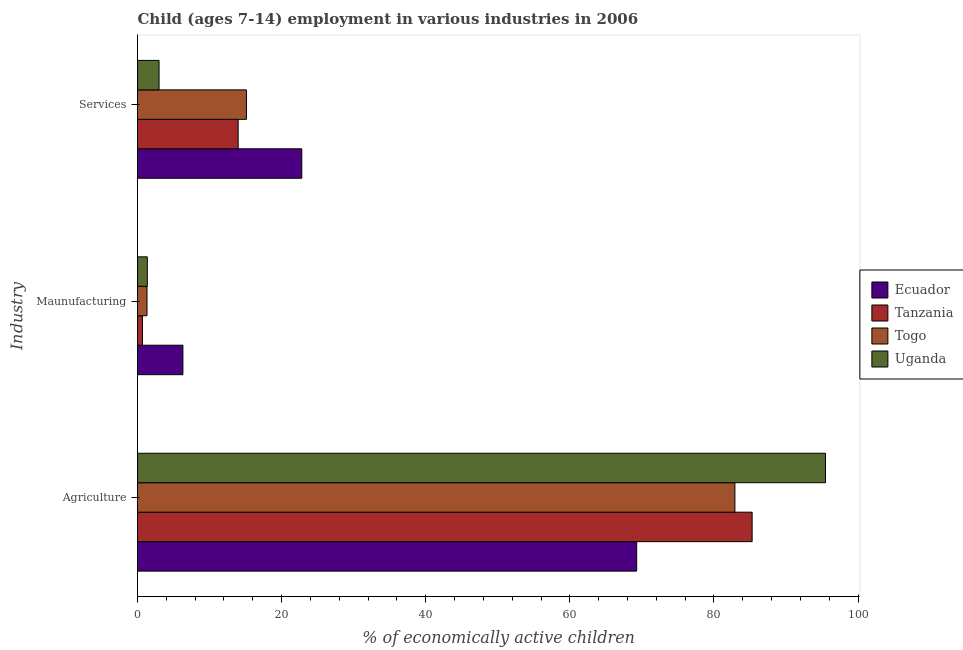Are the number of bars per tick equal to the number of legend labels?
Offer a very short reply. Yes. What is the label of the 3rd group of bars from the top?
Your answer should be very brief. Agriculture. What is the percentage of economically active children in manufacturing in Tanzania?
Provide a succinct answer. 0.69. Across all countries, what is the maximum percentage of economically active children in services?
Keep it short and to the point. 22.8. Across all countries, what is the minimum percentage of economically active children in manufacturing?
Keep it short and to the point. 0.69. In which country was the percentage of economically active children in agriculture maximum?
Give a very brief answer. Uganda. In which country was the percentage of economically active children in manufacturing minimum?
Give a very brief answer. Tanzania. What is the total percentage of economically active children in services in the graph?
Provide a succinct answer. 54.88. What is the difference between the percentage of economically active children in services in Uganda and that in Togo?
Give a very brief answer. -12.13. What is the difference between the percentage of economically active children in services in Ecuador and the percentage of economically active children in agriculture in Togo?
Ensure brevity in your answer.  -60.11. What is the average percentage of economically active children in agriculture per country?
Make the answer very short. 83.24. What is the difference between the percentage of economically active children in services and percentage of economically active children in agriculture in Ecuador?
Provide a succinct answer. -46.48. In how many countries, is the percentage of economically active children in services greater than 52 %?
Offer a terse response. 0. What is the ratio of the percentage of economically active children in agriculture in Ecuador to that in Tanzania?
Provide a succinct answer. 0.81. Is the percentage of economically active children in services in Ecuador less than that in Tanzania?
Provide a short and direct response. No. Is the difference between the percentage of economically active children in manufacturing in Uganda and Ecuador greater than the difference between the percentage of economically active children in services in Uganda and Ecuador?
Your answer should be compact. Yes. What is the difference between the highest and the second highest percentage of economically active children in manufacturing?
Your answer should be very brief. 4.94. What is the difference between the highest and the lowest percentage of economically active children in agriculture?
Make the answer very short. 26.2. In how many countries, is the percentage of economically active children in services greater than the average percentage of economically active children in services taken over all countries?
Offer a terse response. 3. Is the sum of the percentage of economically active children in services in Uganda and Tanzania greater than the maximum percentage of economically active children in manufacturing across all countries?
Offer a very short reply. Yes. What does the 3rd bar from the top in Services represents?
Make the answer very short. Tanzania. What does the 4th bar from the bottom in Agriculture represents?
Ensure brevity in your answer.  Uganda. How many bars are there?
Provide a succinct answer. 12. How many countries are there in the graph?
Your answer should be compact. 4. How many legend labels are there?
Provide a succinct answer. 4. How are the legend labels stacked?
Your answer should be compact. Vertical. What is the title of the graph?
Your answer should be very brief. Child (ages 7-14) employment in various industries in 2006. What is the label or title of the X-axis?
Ensure brevity in your answer.  % of economically active children. What is the label or title of the Y-axis?
Make the answer very short. Industry. What is the % of economically active children in Ecuador in Agriculture?
Offer a terse response. 69.28. What is the % of economically active children in Tanzania in Agriculture?
Provide a short and direct response. 85.3. What is the % of economically active children in Togo in Agriculture?
Give a very brief answer. 82.91. What is the % of economically active children of Uganda in Agriculture?
Your answer should be very brief. 95.48. What is the % of economically active children in Ecuador in Maunufacturing?
Your response must be concise. 6.3. What is the % of economically active children in Tanzania in Maunufacturing?
Keep it short and to the point. 0.69. What is the % of economically active children of Togo in Maunufacturing?
Your response must be concise. 1.32. What is the % of economically active children of Uganda in Maunufacturing?
Ensure brevity in your answer.  1.36. What is the % of economically active children in Ecuador in Services?
Your response must be concise. 22.8. What is the % of economically active children of Tanzania in Services?
Provide a succinct answer. 13.97. What is the % of economically active children of Togo in Services?
Offer a terse response. 15.12. What is the % of economically active children in Uganda in Services?
Give a very brief answer. 2.99. Across all Industry, what is the maximum % of economically active children in Ecuador?
Your response must be concise. 69.28. Across all Industry, what is the maximum % of economically active children of Tanzania?
Offer a terse response. 85.3. Across all Industry, what is the maximum % of economically active children of Togo?
Offer a terse response. 82.91. Across all Industry, what is the maximum % of economically active children in Uganda?
Make the answer very short. 95.48. Across all Industry, what is the minimum % of economically active children in Ecuador?
Offer a very short reply. 6.3. Across all Industry, what is the minimum % of economically active children in Tanzania?
Offer a very short reply. 0.69. Across all Industry, what is the minimum % of economically active children in Togo?
Keep it short and to the point. 1.32. Across all Industry, what is the minimum % of economically active children in Uganda?
Offer a terse response. 1.36. What is the total % of economically active children of Ecuador in the graph?
Your response must be concise. 98.38. What is the total % of economically active children in Tanzania in the graph?
Offer a very short reply. 99.96. What is the total % of economically active children of Togo in the graph?
Your response must be concise. 99.35. What is the total % of economically active children in Uganda in the graph?
Your answer should be very brief. 99.83. What is the difference between the % of economically active children of Ecuador in Agriculture and that in Maunufacturing?
Provide a short and direct response. 62.98. What is the difference between the % of economically active children of Tanzania in Agriculture and that in Maunufacturing?
Your response must be concise. 84.61. What is the difference between the % of economically active children in Togo in Agriculture and that in Maunufacturing?
Ensure brevity in your answer.  81.59. What is the difference between the % of economically active children of Uganda in Agriculture and that in Maunufacturing?
Provide a short and direct response. 94.12. What is the difference between the % of economically active children in Ecuador in Agriculture and that in Services?
Your response must be concise. 46.48. What is the difference between the % of economically active children in Tanzania in Agriculture and that in Services?
Make the answer very short. 71.33. What is the difference between the % of economically active children in Togo in Agriculture and that in Services?
Your answer should be very brief. 67.79. What is the difference between the % of economically active children in Uganda in Agriculture and that in Services?
Offer a terse response. 92.49. What is the difference between the % of economically active children in Ecuador in Maunufacturing and that in Services?
Make the answer very short. -16.5. What is the difference between the % of economically active children in Tanzania in Maunufacturing and that in Services?
Your response must be concise. -13.28. What is the difference between the % of economically active children of Togo in Maunufacturing and that in Services?
Your answer should be compact. -13.8. What is the difference between the % of economically active children of Uganda in Maunufacturing and that in Services?
Ensure brevity in your answer.  -1.63. What is the difference between the % of economically active children of Ecuador in Agriculture and the % of economically active children of Tanzania in Maunufacturing?
Offer a terse response. 68.59. What is the difference between the % of economically active children in Ecuador in Agriculture and the % of economically active children in Togo in Maunufacturing?
Your response must be concise. 67.96. What is the difference between the % of economically active children in Ecuador in Agriculture and the % of economically active children in Uganda in Maunufacturing?
Your answer should be compact. 67.92. What is the difference between the % of economically active children of Tanzania in Agriculture and the % of economically active children of Togo in Maunufacturing?
Make the answer very short. 83.98. What is the difference between the % of economically active children of Tanzania in Agriculture and the % of economically active children of Uganda in Maunufacturing?
Give a very brief answer. 83.94. What is the difference between the % of economically active children in Togo in Agriculture and the % of economically active children in Uganda in Maunufacturing?
Your answer should be very brief. 81.55. What is the difference between the % of economically active children of Ecuador in Agriculture and the % of economically active children of Tanzania in Services?
Ensure brevity in your answer.  55.31. What is the difference between the % of economically active children of Ecuador in Agriculture and the % of economically active children of Togo in Services?
Ensure brevity in your answer.  54.16. What is the difference between the % of economically active children of Ecuador in Agriculture and the % of economically active children of Uganda in Services?
Your answer should be compact. 66.29. What is the difference between the % of economically active children in Tanzania in Agriculture and the % of economically active children in Togo in Services?
Ensure brevity in your answer.  70.18. What is the difference between the % of economically active children of Tanzania in Agriculture and the % of economically active children of Uganda in Services?
Provide a short and direct response. 82.31. What is the difference between the % of economically active children of Togo in Agriculture and the % of economically active children of Uganda in Services?
Ensure brevity in your answer.  79.92. What is the difference between the % of economically active children in Ecuador in Maunufacturing and the % of economically active children in Tanzania in Services?
Provide a short and direct response. -7.67. What is the difference between the % of economically active children in Ecuador in Maunufacturing and the % of economically active children in Togo in Services?
Make the answer very short. -8.82. What is the difference between the % of economically active children of Ecuador in Maunufacturing and the % of economically active children of Uganda in Services?
Make the answer very short. 3.31. What is the difference between the % of economically active children in Tanzania in Maunufacturing and the % of economically active children in Togo in Services?
Provide a short and direct response. -14.43. What is the difference between the % of economically active children of Togo in Maunufacturing and the % of economically active children of Uganda in Services?
Provide a short and direct response. -1.67. What is the average % of economically active children in Ecuador per Industry?
Your answer should be very brief. 32.79. What is the average % of economically active children in Tanzania per Industry?
Provide a short and direct response. 33.32. What is the average % of economically active children in Togo per Industry?
Offer a very short reply. 33.12. What is the average % of economically active children in Uganda per Industry?
Your answer should be compact. 33.28. What is the difference between the % of economically active children of Ecuador and % of economically active children of Tanzania in Agriculture?
Your answer should be compact. -16.02. What is the difference between the % of economically active children of Ecuador and % of economically active children of Togo in Agriculture?
Keep it short and to the point. -13.63. What is the difference between the % of economically active children of Ecuador and % of economically active children of Uganda in Agriculture?
Ensure brevity in your answer.  -26.2. What is the difference between the % of economically active children of Tanzania and % of economically active children of Togo in Agriculture?
Make the answer very short. 2.39. What is the difference between the % of economically active children of Tanzania and % of economically active children of Uganda in Agriculture?
Make the answer very short. -10.18. What is the difference between the % of economically active children of Togo and % of economically active children of Uganda in Agriculture?
Offer a terse response. -12.57. What is the difference between the % of economically active children in Ecuador and % of economically active children in Tanzania in Maunufacturing?
Your answer should be compact. 5.61. What is the difference between the % of economically active children in Ecuador and % of economically active children in Togo in Maunufacturing?
Your response must be concise. 4.98. What is the difference between the % of economically active children in Ecuador and % of economically active children in Uganda in Maunufacturing?
Offer a terse response. 4.94. What is the difference between the % of economically active children in Tanzania and % of economically active children in Togo in Maunufacturing?
Your response must be concise. -0.63. What is the difference between the % of economically active children of Tanzania and % of economically active children of Uganda in Maunufacturing?
Your answer should be very brief. -0.67. What is the difference between the % of economically active children in Togo and % of economically active children in Uganda in Maunufacturing?
Offer a terse response. -0.04. What is the difference between the % of economically active children of Ecuador and % of economically active children of Tanzania in Services?
Make the answer very short. 8.83. What is the difference between the % of economically active children of Ecuador and % of economically active children of Togo in Services?
Your answer should be compact. 7.68. What is the difference between the % of economically active children of Ecuador and % of economically active children of Uganda in Services?
Provide a succinct answer. 19.81. What is the difference between the % of economically active children in Tanzania and % of economically active children in Togo in Services?
Ensure brevity in your answer.  -1.15. What is the difference between the % of economically active children of Tanzania and % of economically active children of Uganda in Services?
Give a very brief answer. 10.98. What is the difference between the % of economically active children in Togo and % of economically active children in Uganda in Services?
Make the answer very short. 12.13. What is the ratio of the % of economically active children in Ecuador in Agriculture to that in Maunufacturing?
Provide a succinct answer. 11. What is the ratio of the % of economically active children in Tanzania in Agriculture to that in Maunufacturing?
Provide a short and direct response. 123.62. What is the ratio of the % of economically active children of Togo in Agriculture to that in Maunufacturing?
Make the answer very short. 62.81. What is the ratio of the % of economically active children in Uganda in Agriculture to that in Maunufacturing?
Provide a short and direct response. 70.21. What is the ratio of the % of economically active children in Ecuador in Agriculture to that in Services?
Make the answer very short. 3.04. What is the ratio of the % of economically active children in Tanzania in Agriculture to that in Services?
Give a very brief answer. 6.11. What is the ratio of the % of economically active children of Togo in Agriculture to that in Services?
Ensure brevity in your answer.  5.48. What is the ratio of the % of economically active children of Uganda in Agriculture to that in Services?
Provide a succinct answer. 31.93. What is the ratio of the % of economically active children of Ecuador in Maunufacturing to that in Services?
Make the answer very short. 0.28. What is the ratio of the % of economically active children in Tanzania in Maunufacturing to that in Services?
Keep it short and to the point. 0.05. What is the ratio of the % of economically active children of Togo in Maunufacturing to that in Services?
Ensure brevity in your answer.  0.09. What is the ratio of the % of economically active children of Uganda in Maunufacturing to that in Services?
Your response must be concise. 0.45. What is the difference between the highest and the second highest % of economically active children of Ecuador?
Your answer should be compact. 46.48. What is the difference between the highest and the second highest % of economically active children of Tanzania?
Your answer should be very brief. 71.33. What is the difference between the highest and the second highest % of economically active children in Togo?
Your answer should be compact. 67.79. What is the difference between the highest and the second highest % of economically active children in Uganda?
Offer a terse response. 92.49. What is the difference between the highest and the lowest % of economically active children of Ecuador?
Provide a short and direct response. 62.98. What is the difference between the highest and the lowest % of economically active children of Tanzania?
Keep it short and to the point. 84.61. What is the difference between the highest and the lowest % of economically active children of Togo?
Your answer should be compact. 81.59. What is the difference between the highest and the lowest % of economically active children of Uganda?
Your response must be concise. 94.12. 